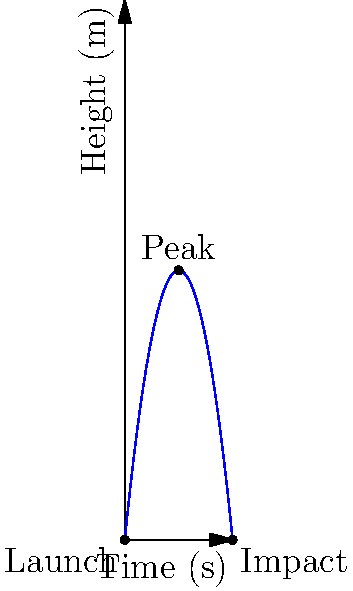In a high-stakes action sequence, a stunt coordinator needs to calculate the precise timing for a projectile launch. The projectile follows a parabolic path as shown in the motion diagram. If the projectile reaches its peak height of 25 meters at t = 5 seconds and impacts the ground at t = 10 seconds, what was its initial vertical velocity (in m/s) at the moment of launch? To solve this problem, we'll use the principles of projectile motion and the given information from the motion diagram. Let's approach this step-by-step:

1) We know that the projectile reaches its peak at t = 5s and falls back to the ground at t = 10s. This means the upward journey takes 5s.

2) In projectile motion, the vertical component of velocity at the peak is zero.

3) We can use the equation: $v = v_0 + at$, where:
   $v$ is the final velocity (0 m/s at peak)
   $v_0$ is the initial velocity (what we're solving for)
   $a$ is the acceleration due to gravity (-9.8 m/s^2)
   $t$ is the time to reach the peak (5s)

4) Substituting these values:
   $0 = v_0 + (-9.8)(5)$

5) Solving for $v_0$:
   $v_0 = 9.8 * 5 = 49$ m/s

6) We can verify this using the equation $y = v_0t - \frac{1}{2}gt^2$:
   $25 = 49(5) - \frac{1}{2}(9.8)(5^2)$
   $25 = 245 - 122.5 = 122.5$ m

   This checks out as the peak height is indeed 25m.

Therefore, the initial vertical velocity of the projectile at launch was 49 m/s upward.
Answer: 49 m/s 